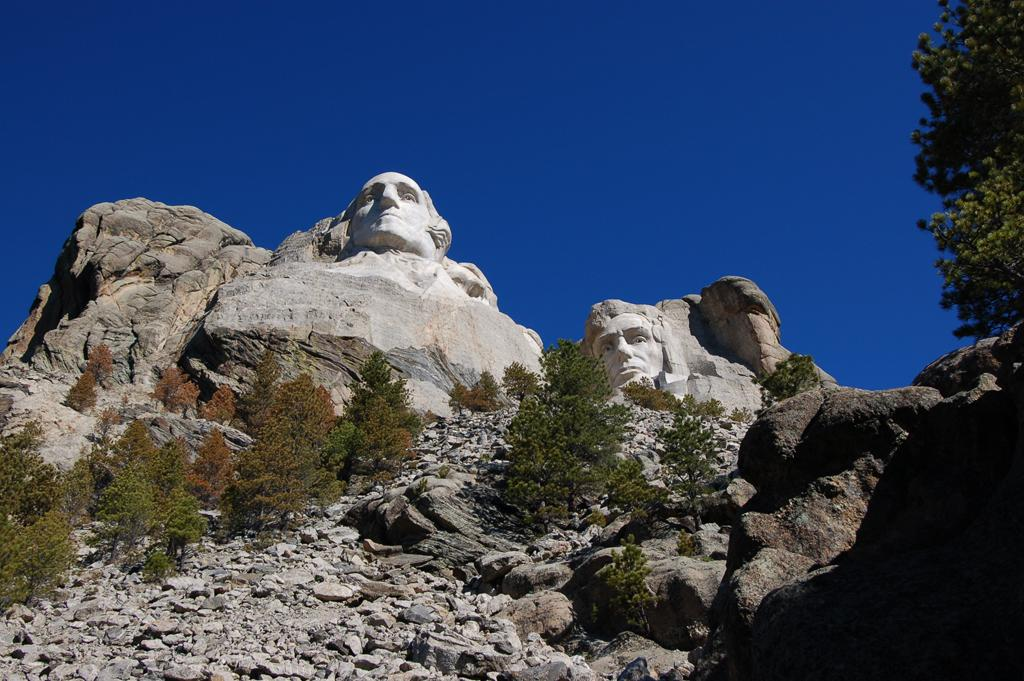What type of artifacts can be seen in the image? There are stone sculptures in the image. What material are the sculptures made of? The sculptures are made of stone. Are there any other stone-related elements in the image? Yes, there are stones and a big rock in the image. What type of natural elements can be seen in the image? There are trees in the image. What is the color of the sky in the image? The sky is blue in the image. Can you see a bomb exploding in the image? No, there is no bomb or explosion present in the image. How many feet are visible in the image? There are no feet visible in the image. 